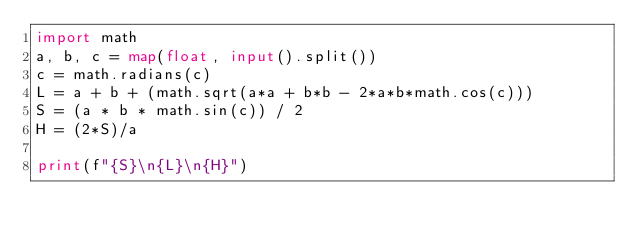Convert code to text. <code><loc_0><loc_0><loc_500><loc_500><_Python_>import math
a, b, c = map(float, input().split())
c = math.radians(c)
L = a + b + (math.sqrt(a*a + b*b - 2*a*b*math.cos(c)))
S = (a * b * math.sin(c)) / 2
H = (2*S)/a

print(f"{S}\n{L}\n{H}")

</code> 